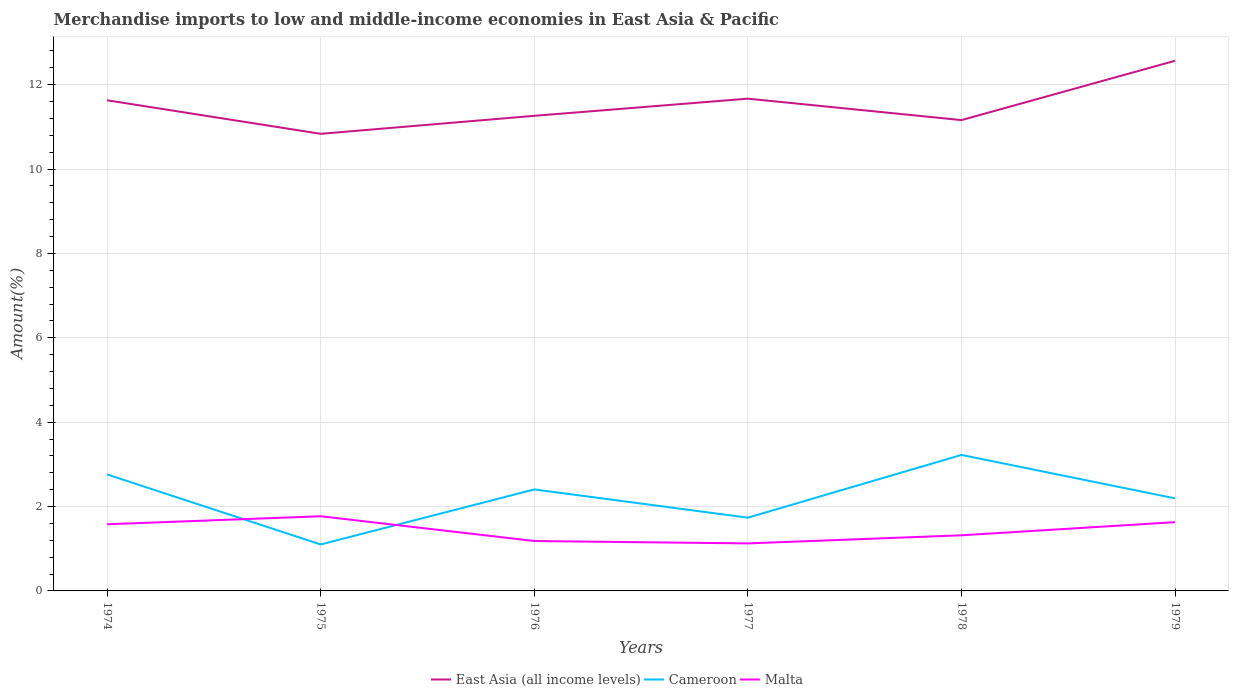How many different coloured lines are there?
Your answer should be compact. 3. Across all years, what is the maximum percentage of amount earned from merchandise imports in Malta?
Your answer should be very brief. 1.13. In which year was the percentage of amount earned from merchandise imports in East Asia (all income levels) maximum?
Make the answer very short. 1975. What is the total percentage of amount earned from merchandise imports in Cameroon in the graph?
Make the answer very short. -1.09. What is the difference between the highest and the second highest percentage of amount earned from merchandise imports in Cameroon?
Offer a very short reply. 2.12. How many years are there in the graph?
Keep it short and to the point. 6. What is the difference between two consecutive major ticks on the Y-axis?
Give a very brief answer. 2. Does the graph contain grids?
Keep it short and to the point. Yes. Where does the legend appear in the graph?
Make the answer very short. Bottom center. How many legend labels are there?
Provide a succinct answer. 3. How are the legend labels stacked?
Ensure brevity in your answer.  Horizontal. What is the title of the graph?
Your answer should be very brief. Merchandise imports to low and middle-income economies in East Asia & Pacific. What is the label or title of the Y-axis?
Make the answer very short. Amount(%). What is the Amount(%) in East Asia (all income levels) in 1974?
Your answer should be very brief. 11.63. What is the Amount(%) of Cameroon in 1974?
Offer a very short reply. 2.76. What is the Amount(%) in Malta in 1974?
Make the answer very short. 1.58. What is the Amount(%) in East Asia (all income levels) in 1975?
Provide a succinct answer. 10.83. What is the Amount(%) of Cameroon in 1975?
Offer a terse response. 1.1. What is the Amount(%) of Malta in 1975?
Keep it short and to the point. 1.77. What is the Amount(%) of East Asia (all income levels) in 1976?
Ensure brevity in your answer.  11.26. What is the Amount(%) of Cameroon in 1976?
Provide a succinct answer. 2.41. What is the Amount(%) in Malta in 1976?
Your response must be concise. 1.18. What is the Amount(%) of East Asia (all income levels) in 1977?
Provide a succinct answer. 11.67. What is the Amount(%) of Cameroon in 1977?
Offer a very short reply. 1.74. What is the Amount(%) of Malta in 1977?
Ensure brevity in your answer.  1.13. What is the Amount(%) of East Asia (all income levels) in 1978?
Your response must be concise. 11.16. What is the Amount(%) of Cameroon in 1978?
Give a very brief answer. 3.22. What is the Amount(%) in Malta in 1978?
Your answer should be compact. 1.32. What is the Amount(%) in East Asia (all income levels) in 1979?
Give a very brief answer. 12.57. What is the Amount(%) in Cameroon in 1979?
Ensure brevity in your answer.  2.19. What is the Amount(%) in Malta in 1979?
Your answer should be very brief. 1.63. Across all years, what is the maximum Amount(%) of East Asia (all income levels)?
Your answer should be compact. 12.57. Across all years, what is the maximum Amount(%) in Cameroon?
Offer a terse response. 3.22. Across all years, what is the maximum Amount(%) in Malta?
Make the answer very short. 1.77. Across all years, what is the minimum Amount(%) of East Asia (all income levels)?
Provide a short and direct response. 10.83. Across all years, what is the minimum Amount(%) in Cameroon?
Offer a very short reply. 1.1. Across all years, what is the minimum Amount(%) in Malta?
Offer a very short reply. 1.13. What is the total Amount(%) of East Asia (all income levels) in the graph?
Offer a very short reply. 69.12. What is the total Amount(%) in Cameroon in the graph?
Give a very brief answer. 13.42. What is the total Amount(%) of Malta in the graph?
Provide a succinct answer. 8.61. What is the difference between the Amount(%) in East Asia (all income levels) in 1974 and that in 1975?
Provide a short and direct response. 0.79. What is the difference between the Amount(%) in Cameroon in 1974 and that in 1975?
Your response must be concise. 1.66. What is the difference between the Amount(%) in Malta in 1974 and that in 1975?
Provide a short and direct response. -0.19. What is the difference between the Amount(%) of East Asia (all income levels) in 1974 and that in 1976?
Ensure brevity in your answer.  0.37. What is the difference between the Amount(%) in Cameroon in 1974 and that in 1976?
Give a very brief answer. 0.36. What is the difference between the Amount(%) of Malta in 1974 and that in 1976?
Offer a terse response. 0.4. What is the difference between the Amount(%) in East Asia (all income levels) in 1974 and that in 1977?
Your response must be concise. -0.04. What is the difference between the Amount(%) of Cameroon in 1974 and that in 1977?
Keep it short and to the point. 1.02. What is the difference between the Amount(%) of Malta in 1974 and that in 1977?
Give a very brief answer. 0.45. What is the difference between the Amount(%) in East Asia (all income levels) in 1974 and that in 1978?
Offer a very short reply. 0.47. What is the difference between the Amount(%) of Cameroon in 1974 and that in 1978?
Your answer should be compact. -0.46. What is the difference between the Amount(%) in Malta in 1974 and that in 1978?
Provide a short and direct response. 0.26. What is the difference between the Amount(%) in East Asia (all income levels) in 1974 and that in 1979?
Make the answer very short. -0.94. What is the difference between the Amount(%) of Cameroon in 1974 and that in 1979?
Your answer should be compact. 0.57. What is the difference between the Amount(%) of Malta in 1974 and that in 1979?
Your response must be concise. -0.05. What is the difference between the Amount(%) in East Asia (all income levels) in 1975 and that in 1976?
Your answer should be compact. -0.43. What is the difference between the Amount(%) in Cameroon in 1975 and that in 1976?
Make the answer very short. -1.3. What is the difference between the Amount(%) in Malta in 1975 and that in 1976?
Offer a very short reply. 0.59. What is the difference between the Amount(%) of Cameroon in 1975 and that in 1977?
Provide a short and direct response. -0.63. What is the difference between the Amount(%) of Malta in 1975 and that in 1977?
Ensure brevity in your answer.  0.64. What is the difference between the Amount(%) in East Asia (all income levels) in 1975 and that in 1978?
Provide a succinct answer. -0.33. What is the difference between the Amount(%) in Cameroon in 1975 and that in 1978?
Provide a short and direct response. -2.12. What is the difference between the Amount(%) of Malta in 1975 and that in 1978?
Provide a succinct answer. 0.45. What is the difference between the Amount(%) of East Asia (all income levels) in 1975 and that in 1979?
Your answer should be very brief. -1.73. What is the difference between the Amount(%) of Cameroon in 1975 and that in 1979?
Make the answer very short. -1.09. What is the difference between the Amount(%) of Malta in 1975 and that in 1979?
Make the answer very short. 0.14. What is the difference between the Amount(%) in East Asia (all income levels) in 1976 and that in 1977?
Ensure brevity in your answer.  -0.41. What is the difference between the Amount(%) in Cameroon in 1976 and that in 1977?
Make the answer very short. 0.67. What is the difference between the Amount(%) in Malta in 1976 and that in 1977?
Ensure brevity in your answer.  0.06. What is the difference between the Amount(%) of East Asia (all income levels) in 1976 and that in 1978?
Give a very brief answer. 0.1. What is the difference between the Amount(%) in Cameroon in 1976 and that in 1978?
Ensure brevity in your answer.  -0.82. What is the difference between the Amount(%) in Malta in 1976 and that in 1978?
Ensure brevity in your answer.  -0.14. What is the difference between the Amount(%) of East Asia (all income levels) in 1976 and that in 1979?
Your answer should be very brief. -1.3. What is the difference between the Amount(%) in Cameroon in 1976 and that in 1979?
Your response must be concise. 0.21. What is the difference between the Amount(%) in Malta in 1976 and that in 1979?
Your answer should be compact. -0.45. What is the difference between the Amount(%) of East Asia (all income levels) in 1977 and that in 1978?
Your answer should be compact. 0.51. What is the difference between the Amount(%) in Cameroon in 1977 and that in 1978?
Your answer should be very brief. -1.49. What is the difference between the Amount(%) in Malta in 1977 and that in 1978?
Provide a succinct answer. -0.19. What is the difference between the Amount(%) in East Asia (all income levels) in 1977 and that in 1979?
Make the answer very short. -0.9. What is the difference between the Amount(%) of Cameroon in 1977 and that in 1979?
Ensure brevity in your answer.  -0.46. What is the difference between the Amount(%) in Malta in 1977 and that in 1979?
Your answer should be very brief. -0.5. What is the difference between the Amount(%) in East Asia (all income levels) in 1978 and that in 1979?
Give a very brief answer. -1.41. What is the difference between the Amount(%) of Cameroon in 1978 and that in 1979?
Provide a succinct answer. 1.03. What is the difference between the Amount(%) in Malta in 1978 and that in 1979?
Make the answer very short. -0.31. What is the difference between the Amount(%) in East Asia (all income levels) in 1974 and the Amount(%) in Cameroon in 1975?
Offer a very short reply. 10.53. What is the difference between the Amount(%) in East Asia (all income levels) in 1974 and the Amount(%) in Malta in 1975?
Your response must be concise. 9.86. What is the difference between the Amount(%) of Cameroon in 1974 and the Amount(%) of Malta in 1975?
Offer a very short reply. 0.99. What is the difference between the Amount(%) of East Asia (all income levels) in 1974 and the Amount(%) of Cameroon in 1976?
Give a very brief answer. 9.22. What is the difference between the Amount(%) in East Asia (all income levels) in 1974 and the Amount(%) in Malta in 1976?
Keep it short and to the point. 10.45. What is the difference between the Amount(%) of Cameroon in 1974 and the Amount(%) of Malta in 1976?
Your answer should be compact. 1.58. What is the difference between the Amount(%) of East Asia (all income levels) in 1974 and the Amount(%) of Cameroon in 1977?
Offer a very short reply. 9.89. What is the difference between the Amount(%) of East Asia (all income levels) in 1974 and the Amount(%) of Malta in 1977?
Your response must be concise. 10.5. What is the difference between the Amount(%) in Cameroon in 1974 and the Amount(%) in Malta in 1977?
Provide a short and direct response. 1.63. What is the difference between the Amount(%) of East Asia (all income levels) in 1974 and the Amount(%) of Cameroon in 1978?
Provide a succinct answer. 8.41. What is the difference between the Amount(%) of East Asia (all income levels) in 1974 and the Amount(%) of Malta in 1978?
Provide a succinct answer. 10.31. What is the difference between the Amount(%) in Cameroon in 1974 and the Amount(%) in Malta in 1978?
Provide a succinct answer. 1.44. What is the difference between the Amount(%) of East Asia (all income levels) in 1974 and the Amount(%) of Cameroon in 1979?
Provide a succinct answer. 9.43. What is the difference between the Amount(%) of East Asia (all income levels) in 1974 and the Amount(%) of Malta in 1979?
Offer a terse response. 10. What is the difference between the Amount(%) in Cameroon in 1974 and the Amount(%) in Malta in 1979?
Give a very brief answer. 1.13. What is the difference between the Amount(%) in East Asia (all income levels) in 1975 and the Amount(%) in Cameroon in 1976?
Offer a very short reply. 8.43. What is the difference between the Amount(%) in East Asia (all income levels) in 1975 and the Amount(%) in Malta in 1976?
Offer a terse response. 9.65. What is the difference between the Amount(%) in Cameroon in 1975 and the Amount(%) in Malta in 1976?
Give a very brief answer. -0.08. What is the difference between the Amount(%) of East Asia (all income levels) in 1975 and the Amount(%) of Cameroon in 1977?
Give a very brief answer. 9.1. What is the difference between the Amount(%) in East Asia (all income levels) in 1975 and the Amount(%) in Malta in 1977?
Ensure brevity in your answer.  9.71. What is the difference between the Amount(%) of Cameroon in 1975 and the Amount(%) of Malta in 1977?
Offer a very short reply. -0.02. What is the difference between the Amount(%) in East Asia (all income levels) in 1975 and the Amount(%) in Cameroon in 1978?
Give a very brief answer. 7.61. What is the difference between the Amount(%) of East Asia (all income levels) in 1975 and the Amount(%) of Malta in 1978?
Your answer should be very brief. 9.52. What is the difference between the Amount(%) of Cameroon in 1975 and the Amount(%) of Malta in 1978?
Offer a very short reply. -0.22. What is the difference between the Amount(%) of East Asia (all income levels) in 1975 and the Amount(%) of Cameroon in 1979?
Offer a very short reply. 8.64. What is the difference between the Amount(%) in East Asia (all income levels) in 1975 and the Amount(%) in Malta in 1979?
Give a very brief answer. 9.2. What is the difference between the Amount(%) in Cameroon in 1975 and the Amount(%) in Malta in 1979?
Make the answer very short. -0.53. What is the difference between the Amount(%) of East Asia (all income levels) in 1976 and the Amount(%) of Cameroon in 1977?
Provide a succinct answer. 9.52. What is the difference between the Amount(%) in East Asia (all income levels) in 1976 and the Amount(%) in Malta in 1977?
Your response must be concise. 10.13. What is the difference between the Amount(%) in Cameroon in 1976 and the Amount(%) in Malta in 1977?
Offer a very short reply. 1.28. What is the difference between the Amount(%) in East Asia (all income levels) in 1976 and the Amount(%) in Cameroon in 1978?
Offer a very short reply. 8.04. What is the difference between the Amount(%) in East Asia (all income levels) in 1976 and the Amount(%) in Malta in 1978?
Give a very brief answer. 9.94. What is the difference between the Amount(%) in Cameroon in 1976 and the Amount(%) in Malta in 1978?
Keep it short and to the point. 1.09. What is the difference between the Amount(%) of East Asia (all income levels) in 1976 and the Amount(%) of Cameroon in 1979?
Ensure brevity in your answer.  9.07. What is the difference between the Amount(%) in East Asia (all income levels) in 1976 and the Amount(%) in Malta in 1979?
Your answer should be compact. 9.63. What is the difference between the Amount(%) in Cameroon in 1976 and the Amount(%) in Malta in 1979?
Make the answer very short. 0.78. What is the difference between the Amount(%) of East Asia (all income levels) in 1977 and the Amount(%) of Cameroon in 1978?
Provide a succinct answer. 8.44. What is the difference between the Amount(%) in East Asia (all income levels) in 1977 and the Amount(%) in Malta in 1978?
Offer a very short reply. 10.35. What is the difference between the Amount(%) of Cameroon in 1977 and the Amount(%) of Malta in 1978?
Give a very brief answer. 0.42. What is the difference between the Amount(%) of East Asia (all income levels) in 1977 and the Amount(%) of Cameroon in 1979?
Your answer should be compact. 9.47. What is the difference between the Amount(%) in East Asia (all income levels) in 1977 and the Amount(%) in Malta in 1979?
Provide a short and direct response. 10.04. What is the difference between the Amount(%) in Cameroon in 1977 and the Amount(%) in Malta in 1979?
Your answer should be very brief. 0.11. What is the difference between the Amount(%) of East Asia (all income levels) in 1978 and the Amount(%) of Cameroon in 1979?
Make the answer very short. 8.97. What is the difference between the Amount(%) in East Asia (all income levels) in 1978 and the Amount(%) in Malta in 1979?
Ensure brevity in your answer.  9.53. What is the difference between the Amount(%) of Cameroon in 1978 and the Amount(%) of Malta in 1979?
Your response must be concise. 1.59. What is the average Amount(%) in East Asia (all income levels) per year?
Offer a very short reply. 11.52. What is the average Amount(%) in Cameroon per year?
Provide a short and direct response. 2.24. What is the average Amount(%) in Malta per year?
Your answer should be compact. 1.43. In the year 1974, what is the difference between the Amount(%) of East Asia (all income levels) and Amount(%) of Cameroon?
Give a very brief answer. 8.87. In the year 1974, what is the difference between the Amount(%) in East Asia (all income levels) and Amount(%) in Malta?
Give a very brief answer. 10.05. In the year 1974, what is the difference between the Amount(%) in Cameroon and Amount(%) in Malta?
Your answer should be compact. 1.18. In the year 1975, what is the difference between the Amount(%) of East Asia (all income levels) and Amount(%) of Cameroon?
Keep it short and to the point. 9.73. In the year 1975, what is the difference between the Amount(%) in East Asia (all income levels) and Amount(%) in Malta?
Your answer should be compact. 9.06. In the year 1975, what is the difference between the Amount(%) of Cameroon and Amount(%) of Malta?
Provide a short and direct response. -0.67. In the year 1976, what is the difference between the Amount(%) of East Asia (all income levels) and Amount(%) of Cameroon?
Your answer should be very brief. 8.86. In the year 1976, what is the difference between the Amount(%) in East Asia (all income levels) and Amount(%) in Malta?
Your answer should be compact. 10.08. In the year 1976, what is the difference between the Amount(%) in Cameroon and Amount(%) in Malta?
Provide a succinct answer. 1.22. In the year 1977, what is the difference between the Amount(%) of East Asia (all income levels) and Amount(%) of Cameroon?
Offer a terse response. 9.93. In the year 1977, what is the difference between the Amount(%) of East Asia (all income levels) and Amount(%) of Malta?
Keep it short and to the point. 10.54. In the year 1977, what is the difference between the Amount(%) of Cameroon and Amount(%) of Malta?
Your response must be concise. 0.61. In the year 1978, what is the difference between the Amount(%) of East Asia (all income levels) and Amount(%) of Cameroon?
Your answer should be very brief. 7.94. In the year 1978, what is the difference between the Amount(%) in East Asia (all income levels) and Amount(%) in Malta?
Offer a terse response. 9.84. In the year 1978, what is the difference between the Amount(%) of Cameroon and Amount(%) of Malta?
Make the answer very short. 1.91. In the year 1979, what is the difference between the Amount(%) of East Asia (all income levels) and Amount(%) of Cameroon?
Give a very brief answer. 10.37. In the year 1979, what is the difference between the Amount(%) of East Asia (all income levels) and Amount(%) of Malta?
Make the answer very short. 10.94. In the year 1979, what is the difference between the Amount(%) of Cameroon and Amount(%) of Malta?
Your answer should be compact. 0.56. What is the ratio of the Amount(%) of East Asia (all income levels) in 1974 to that in 1975?
Offer a terse response. 1.07. What is the ratio of the Amount(%) in Cameroon in 1974 to that in 1975?
Offer a terse response. 2.51. What is the ratio of the Amount(%) in Malta in 1974 to that in 1975?
Make the answer very short. 0.89. What is the ratio of the Amount(%) of East Asia (all income levels) in 1974 to that in 1976?
Your answer should be compact. 1.03. What is the ratio of the Amount(%) of Cameroon in 1974 to that in 1976?
Your response must be concise. 1.15. What is the ratio of the Amount(%) of Malta in 1974 to that in 1976?
Provide a short and direct response. 1.34. What is the ratio of the Amount(%) in East Asia (all income levels) in 1974 to that in 1977?
Your answer should be very brief. 1. What is the ratio of the Amount(%) of Cameroon in 1974 to that in 1977?
Ensure brevity in your answer.  1.59. What is the ratio of the Amount(%) of Malta in 1974 to that in 1977?
Ensure brevity in your answer.  1.4. What is the ratio of the Amount(%) in East Asia (all income levels) in 1974 to that in 1978?
Ensure brevity in your answer.  1.04. What is the ratio of the Amount(%) in Cameroon in 1974 to that in 1978?
Offer a very short reply. 0.86. What is the ratio of the Amount(%) of Malta in 1974 to that in 1978?
Your answer should be very brief. 1.2. What is the ratio of the Amount(%) of East Asia (all income levels) in 1974 to that in 1979?
Provide a short and direct response. 0.93. What is the ratio of the Amount(%) of Cameroon in 1974 to that in 1979?
Keep it short and to the point. 1.26. What is the ratio of the Amount(%) in Malta in 1974 to that in 1979?
Your response must be concise. 0.97. What is the ratio of the Amount(%) in East Asia (all income levels) in 1975 to that in 1976?
Keep it short and to the point. 0.96. What is the ratio of the Amount(%) of Cameroon in 1975 to that in 1976?
Your answer should be compact. 0.46. What is the ratio of the Amount(%) in Malta in 1975 to that in 1976?
Your answer should be very brief. 1.5. What is the ratio of the Amount(%) in East Asia (all income levels) in 1975 to that in 1977?
Make the answer very short. 0.93. What is the ratio of the Amount(%) of Cameroon in 1975 to that in 1977?
Offer a terse response. 0.63. What is the ratio of the Amount(%) of Malta in 1975 to that in 1977?
Offer a very short reply. 1.57. What is the ratio of the Amount(%) in East Asia (all income levels) in 1975 to that in 1978?
Provide a short and direct response. 0.97. What is the ratio of the Amount(%) in Cameroon in 1975 to that in 1978?
Your answer should be very brief. 0.34. What is the ratio of the Amount(%) of Malta in 1975 to that in 1978?
Offer a very short reply. 1.34. What is the ratio of the Amount(%) in East Asia (all income levels) in 1975 to that in 1979?
Offer a terse response. 0.86. What is the ratio of the Amount(%) in Cameroon in 1975 to that in 1979?
Provide a short and direct response. 0.5. What is the ratio of the Amount(%) in Malta in 1975 to that in 1979?
Offer a terse response. 1.09. What is the ratio of the Amount(%) in East Asia (all income levels) in 1976 to that in 1977?
Provide a short and direct response. 0.97. What is the ratio of the Amount(%) of Cameroon in 1976 to that in 1977?
Provide a short and direct response. 1.39. What is the ratio of the Amount(%) of Malta in 1976 to that in 1977?
Ensure brevity in your answer.  1.05. What is the ratio of the Amount(%) in East Asia (all income levels) in 1976 to that in 1978?
Your response must be concise. 1.01. What is the ratio of the Amount(%) in Cameroon in 1976 to that in 1978?
Offer a very short reply. 0.75. What is the ratio of the Amount(%) in Malta in 1976 to that in 1978?
Your answer should be very brief. 0.9. What is the ratio of the Amount(%) in East Asia (all income levels) in 1976 to that in 1979?
Offer a terse response. 0.9. What is the ratio of the Amount(%) of Cameroon in 1976 to that in 1979?
Your response must be concise. 1.1. What is the ratio of the Amount(%) in Malta in 1976 to that in 1979?
Make the answer very short. 0.73. What is the ratio of the Amount(%) of East Asia (all income levels) in 1977 to that in 1978?
Your response must be concise. 1.05. What is the ratio of the Amount(%) in Cameroon in 1977 to that in 1978?
Offer a terse response. 0.54. What is the ratio of the Amount(%) in Malta in 1977 to that in 1978?
Offer a terse response. 0.85. What is the ratio of the Amount(%) of East Asia (all income levels) in 1977 to that in 1979?
Offer a very short reply. 0.93. What is the ratio of the Amount(%) in Cameroon in 1977 to that in 1979?
Offer a terse response. 0.79. What is the ratio of the Amount(%) in Malta in 1977 to that in 1979?
Provide a succinct answer. 0.69. What is the ratio of the Amount(%) of East Asia (all income levels) in 1978 to that in 1979?
Your answer should be very brief. 0.89. What is the ratio of the Amount(%) of Cameroon in 1978 to that in 1979?
Keep it short and to the point. 1.47. What is the ratio of the Amount(%) of Malta in 1978 to that in 1979?
Keep it short and to the point. 0.81. What is the difference between the highest and the second highest Amount(%) in East Asia (all income levels)?
Keep it short and to the point. 0.9. What is the difference between the highest and the second highest Amount(%) of Cameroon?
Your answer should be compact. 0.46. What is the difference between the highest and the second highest Amount(%) of Malta?
Offer a very short reply. 0.14. What is the difference between the highest and the lowest Amount(%) of East Asia (all income levels)?
Provide a short and direct response. 1.73. What is the difference between the highest and the lowest Amount(%) of Cameroon?
Give a very brief answer. 2.12. What is the difference between the highest and the lowest Amount(%) in Malta?
Offer a terse response. 0.64. 